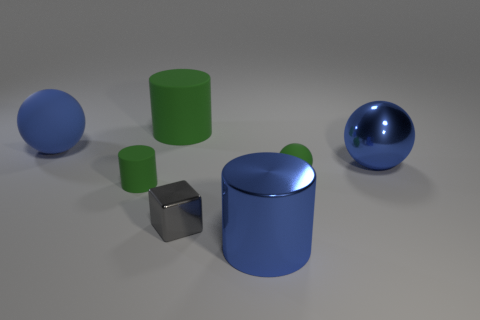Is there any other thing that has the same shape as the small gray object?
Ensure brevity in your answer.  No. Is the number of tiny matte objects behind the tiny matte cylinder less than the number of metal things that are to the right of the small gray thing?
Give a very brief answer. Yes. The small thing that is to the left of the large green matte cylinder is what color?
Keep it short and to the point. Green. What number of other things are there of the same color as the small rubber cylinder?
Offer a very short reply. 2. Do the green cylinder that is behind the green rubber sphere and the tiny matte sphere have the same size?
Your answer should be compact. No. There is a metal cube; how many large metal balls are to the left of it?
Offer a terse response. 0. Are there any green rubber things that have the same size as the blue matte object?
Keep it short and to the point. Yes. Is the color of the large metallic sphere the same as the metal cylinder?
Offer a very short reply. Yes. The big ball that is to the right of the large thing behind the large matte ball is what color?
Your answer should be compact. Blue. What number of big objects are both behind the gray block and on the left side of the small green matte ball?
Give a very brief answer. 2. 